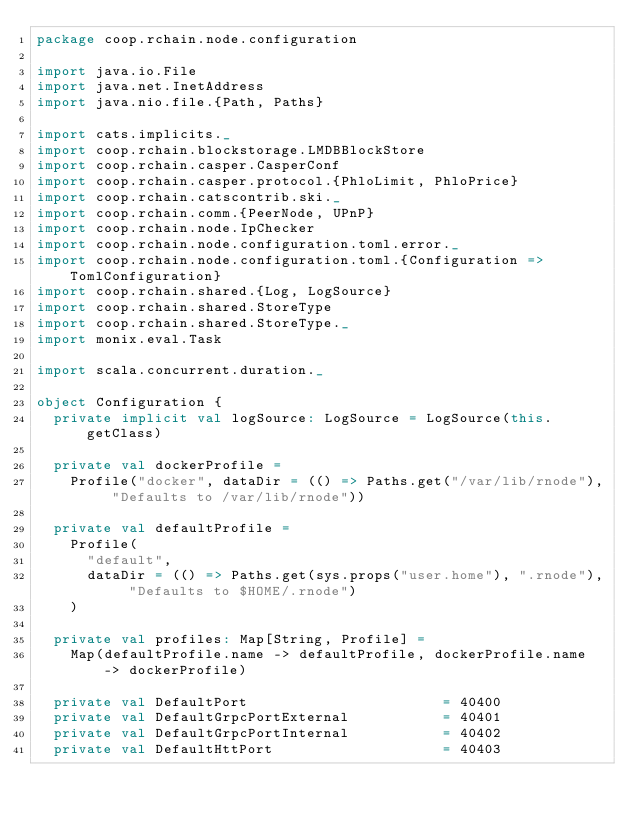Convert code to text. <code><loc_0><loc_0><loc_500><loc_500><_Scala_>package coop.rchain.node.configuration

import java.io.File
import java.net.InetAddress
import java.nio.file.{Path, Paths}

import cats.implicits._
import coop.rchain.blockstorage.LMDBBlockStore
import coop.rchain.casper.CasperConf
import coop.rchain.casper.protocol.{PhloLimit, PhloPrice}
import coop.rchain.catscontrib.ski._
import coop.rchain.comm.{PeerNode, UPnP}
import coop.rchain.node.IpChecker
import coop.rchain.node.configuration.toml.error._
import coop.rchain.node.configuration.toml.{Configuration => TomlConfiguration}
import coop.rchain.shared.{Log, LogSource}
import coop.rchain.shared.StoreType
import coop.rchain.shared.StoreType._
import monix.eval.Task

import scala.concurrent.duration._

object Configuration {
  private implicit val logSource: LogSource = LogSource(this.getClass)

  private val dockerProfile =
    Profile("docker", dataDir = (() => Paths.get("/var/lib/rnode"), "Defaults to /var/lib/rnode"))

  private val defaultProfile =
    Profile(
      "default",
      dataDir = (() => Paths.get(sys.props("user.home"), ".rnode"), "Defaults to $HOME/.rnode")
    )

  private val profiles: Map[String, Profile] =
    Map(defaultProfile.name -> defaultProfile, dockerProfile.name -> dockerProfile)

  private val DefaultPort                       = 40400
  private val DefaultGrpcPortExternal           = 40401
  private val DefaultGrpcPortInternal           = 40402
  private val DefaultHttPort                    = 40403</code> 